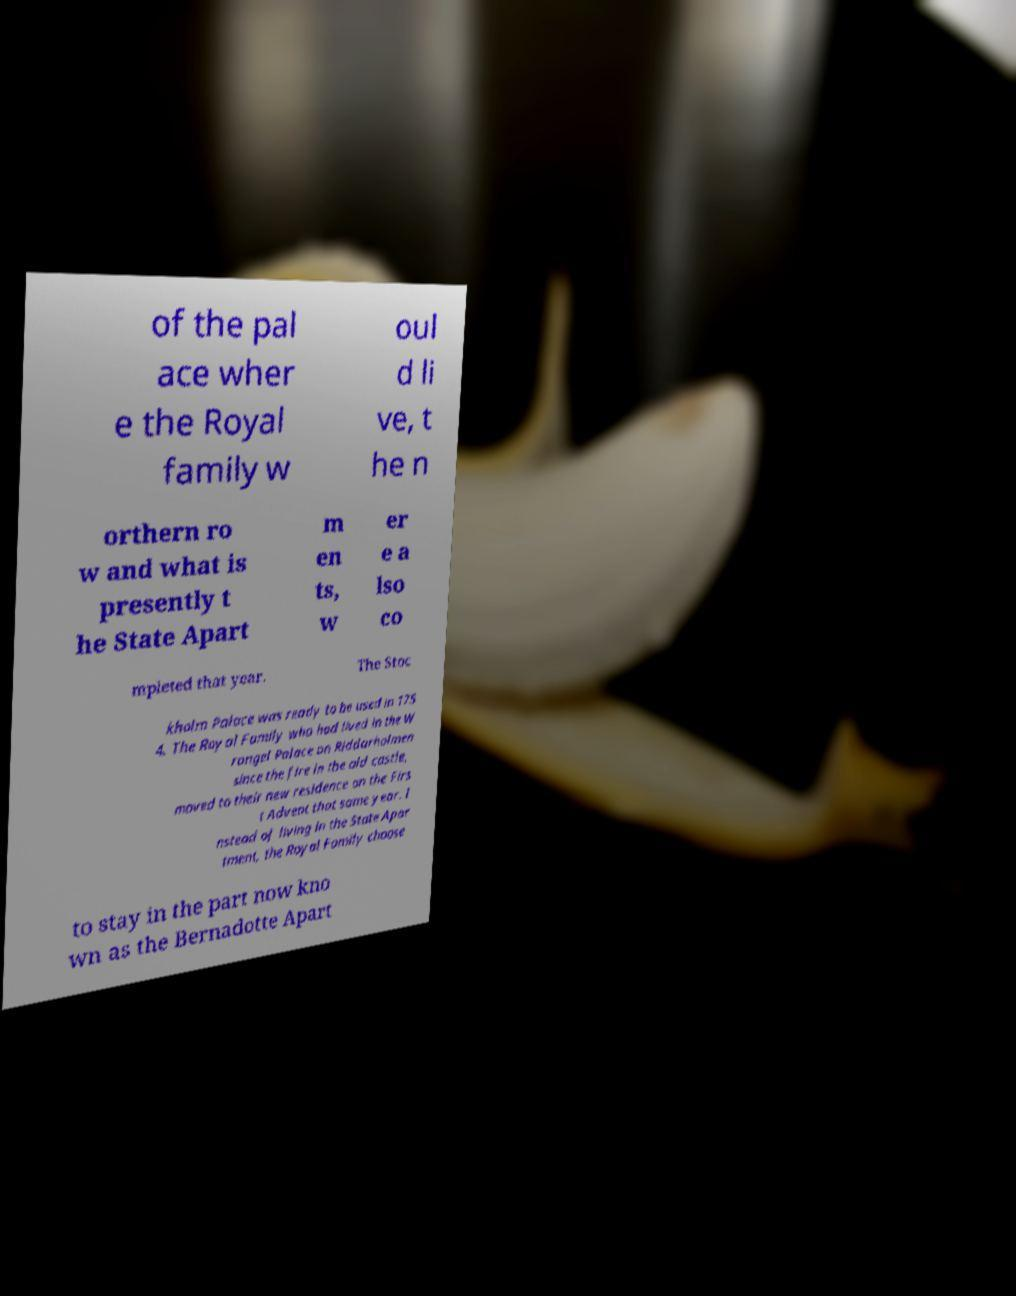Please read and relay the text visible in this image. What does it say? of the pal ace wher e the Royal family w oul d li ve, t he n orthern ro w and what is presently t he State Apart m en ts, w er e a lso co mpleted that year. The Stoc kholm Palace was ready to be used in 175 4. The Royal Family who had lived in the W rangel Palace on Riddarholmen since the fire in the old castle, moved to their new residence on the Firs t Advent that same year. I nstead of living in the State Apar tment, the Royal Family choose to stay in the part now kno wn as the Bernadotte Apart 